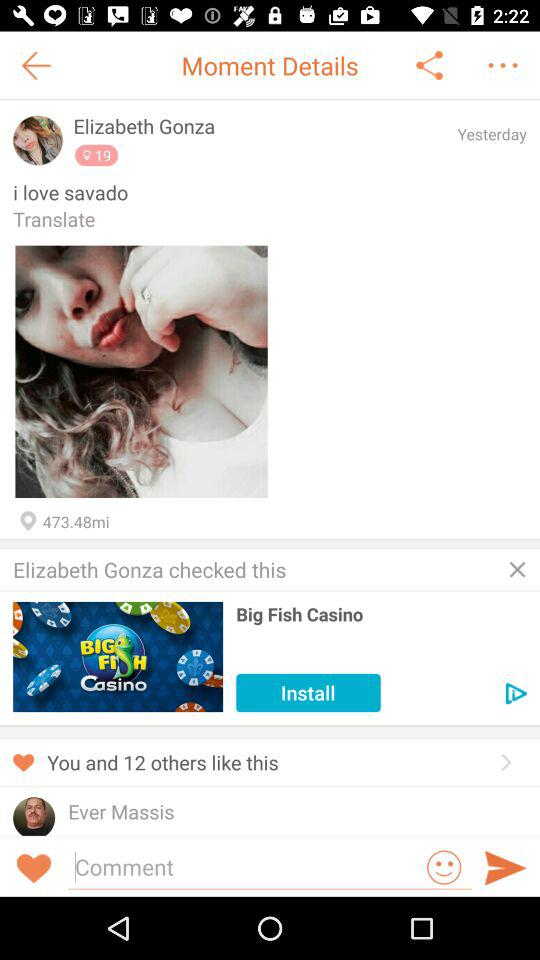What app did Elizabeth check? Elizabeth checked the "Big Fish Casino" app. 